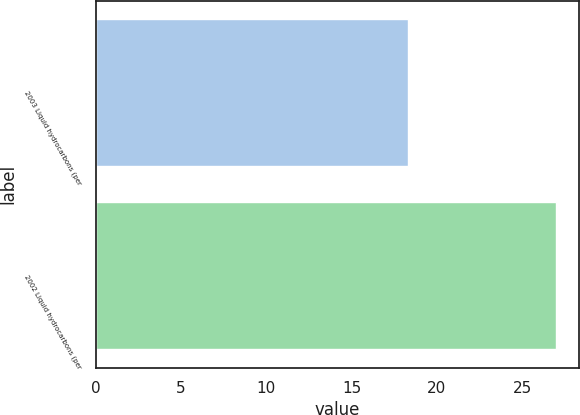Convert chart to OTSL. <chart><loc_0><loc_0><loc_500><loc_500><bar_chart><fcel>2003 Liquid hydrocarbons (per<fcel>2002 Liquid hydrocarbons (per<nl><fcel>18.33<fcel>26.98<nl></chart> 